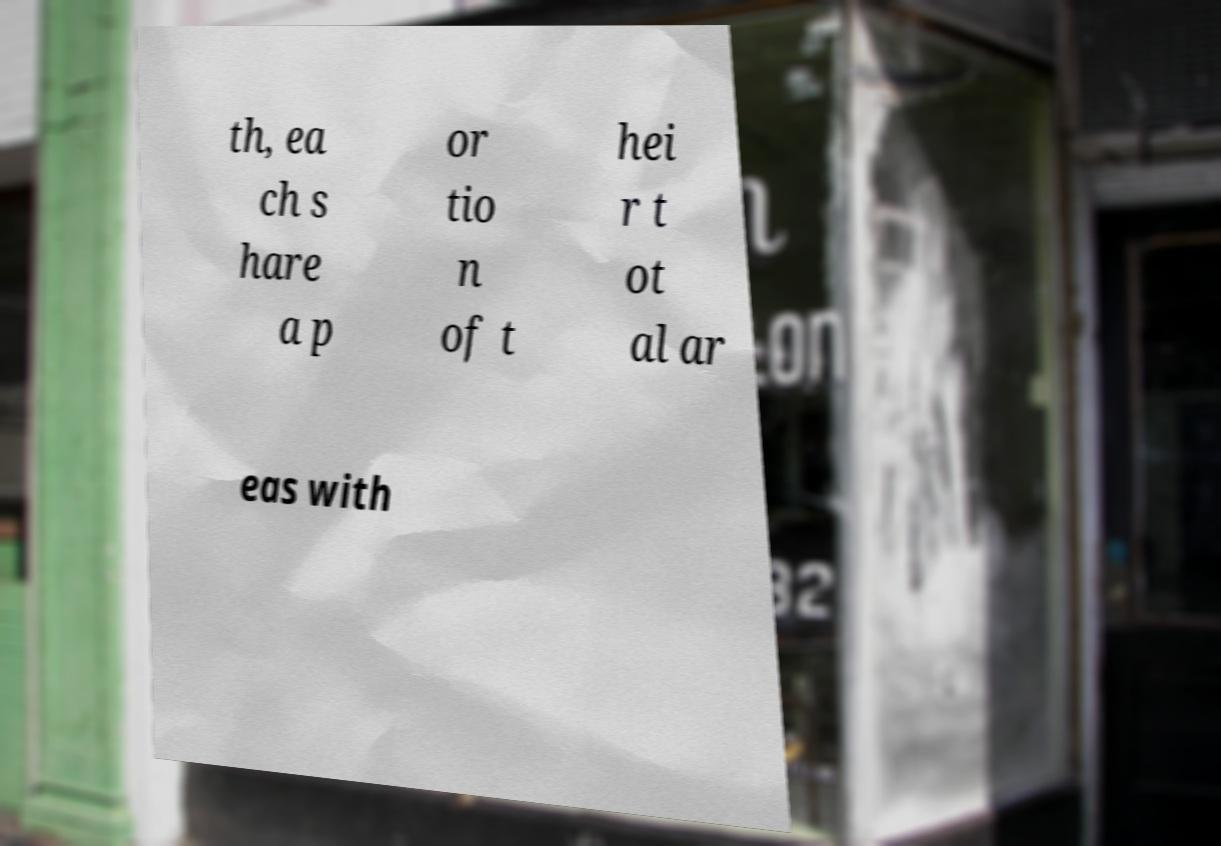There's text embedded in this image that I need extracted. Can you transcribe it verbatim? th, ea ch s hare a p or tio n of t hei r t ot al ar eas with 